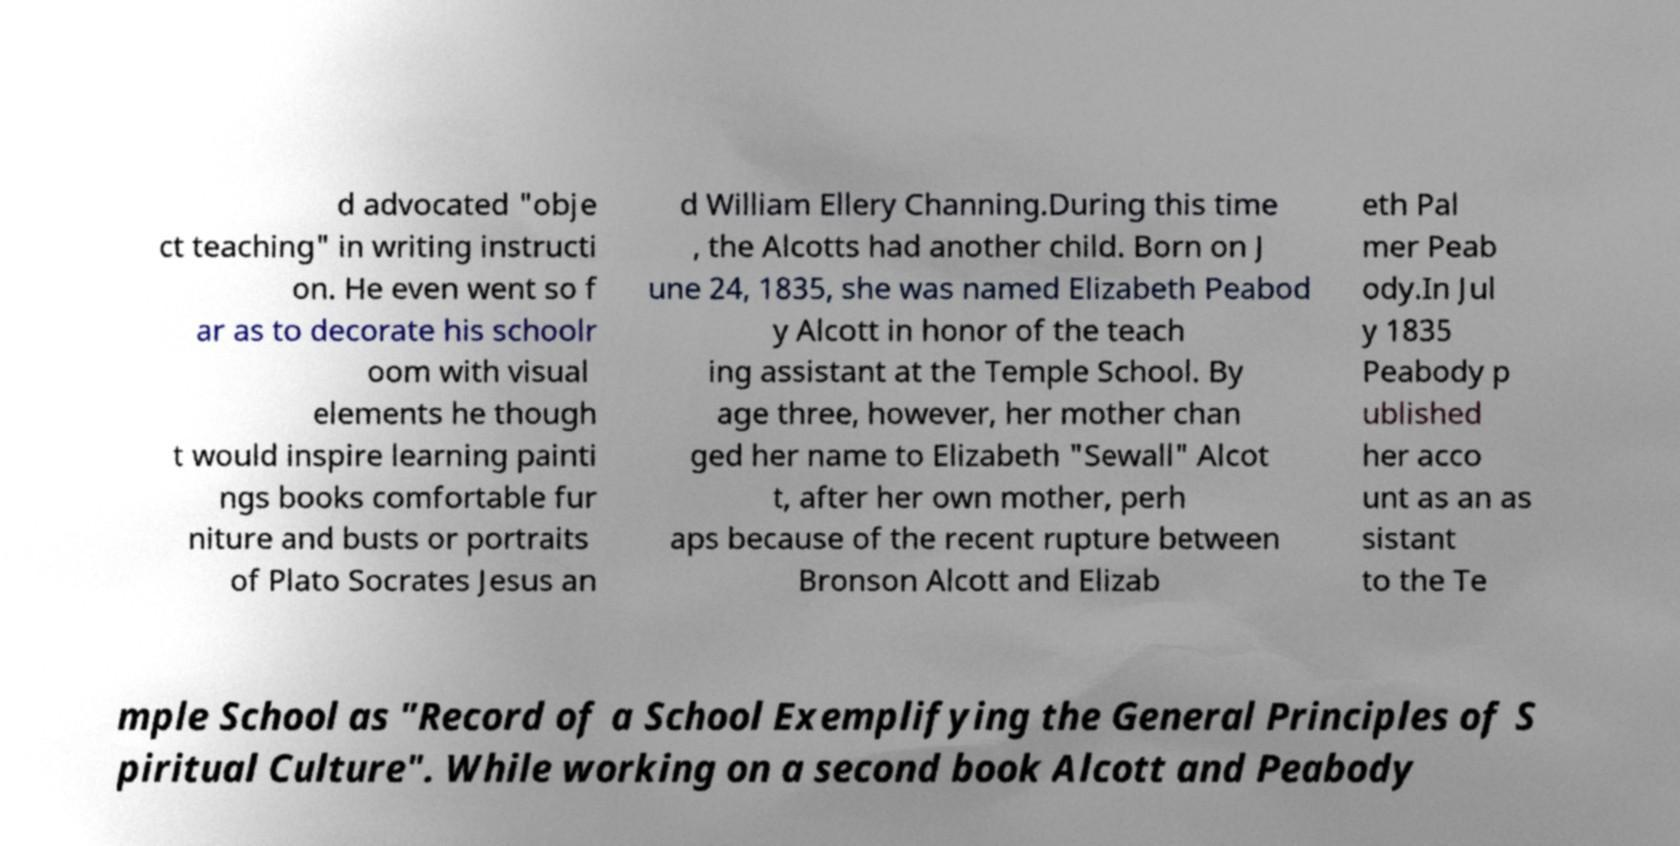Please read and relay the text visible in this image. What does it say? d advocated "obje ct teaching" in writing instructi on. He even went so f ar as to decorate his schoolr oom with visual elements he though t would inspire learning painti ngs books comfortable fur niture and busts or portraits of Plato Socrates Jesus an d William Ellery Channing.During this time , the Alcotts had another child. Born on J une 24, 1835, she was named Elizabeth Peabod y Alcott in honor of the teach ing assistant at the Temple School. By age three, however, her mother chan ged her name to Elizabeth "Sewall" Alcot t, after her own mother, perh aps because of the recent rupture between Bronson Alcott and Elizab eth Pal mer Peab ody.In Jul y 1835 Peabody p ublished her acco unt as an as sistant to the Te mple School as "Record of a School Exemplifying the General Principles of S piritual Culture". While working on a second book Alcott and Peabody 